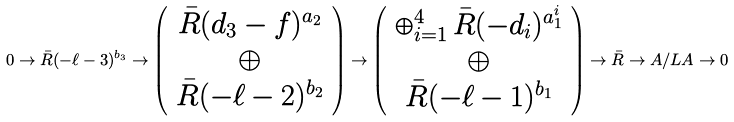<formula> <loc_0><loc_0><loc_500><loc_500>0 \rightarrow { \bar { R } } ( - \ell - 3 ) ^ { b _ { 3 } } \rightarrow \left ( \begin{array} { c } \bar { R } ( d _ { 3 } - f ) ^ { a _ { 2 } } \\ \oplus \\ { \bar { R } } ( - \ell - 2 ) ^ { b _ { 2 } } \end{array} \right ) \rightarrow \left ( \begin{array} { c } \bigoplus _ { i = 1 } ^ { 4 } \bar { R } ( - d _ { i } ) ^ { a ^ { i } _ { 1 } } \\ \oplus \\ { \bar { R } } ( - \ell - 1 ) ^ { b _ { 1 } } \end{array} \right ) \rightarrow \bar { R } \rightarrow A / L A \rightarrow 0</formula> 